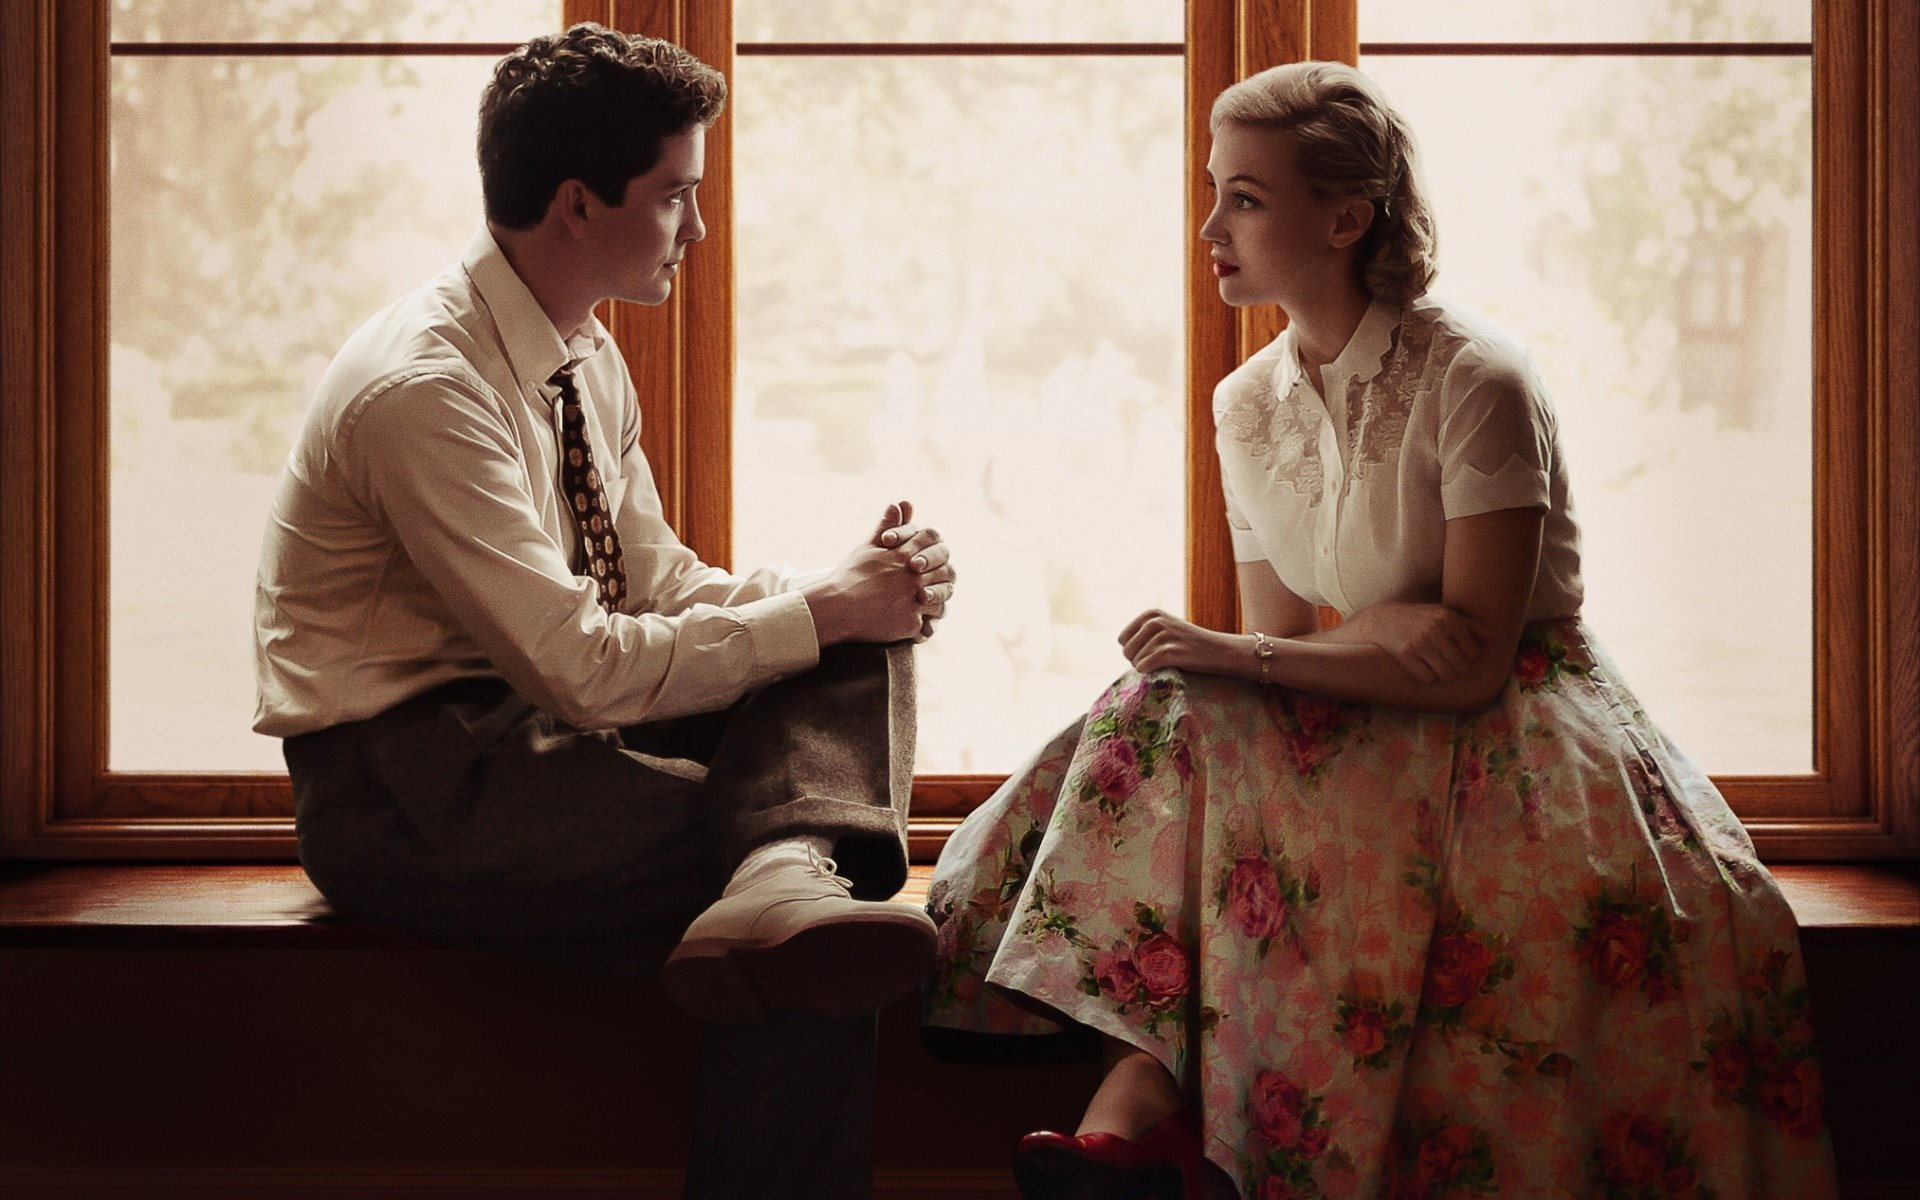What emotions does this image evoke, and how does the color palette contribute to that? The image evokes a sense of nostalgia and introspection, underscored by a color palette that uses a lot of soft, natural tones. The warm browns and greys of the man's attire blend seamlessly with the earthy backdrop, while the woman's floral dress introduces gentle splashes of color, injecting a subtle vibrancy and warmth into the scene. The overall muted, yet warm palette helps convey a calm, reflective mood, enhancing the emotional depth of their interaction. How do the fashion elements in this image contribute to its overall aesthetic? The fashion elements in this image play a critical role in enhancing its aesthetic. The woman's lace blouse and floral skirt, paired with striking red heels, add a touch of sophistication and femininity. The man's vintage-inspired suspender and tie ensemble exudes a classic, timeless charm. Together, these elements not only reinforce the period setting but also add texture and visual interest, contributing to the image's overall elegance and stylistic coherence. 